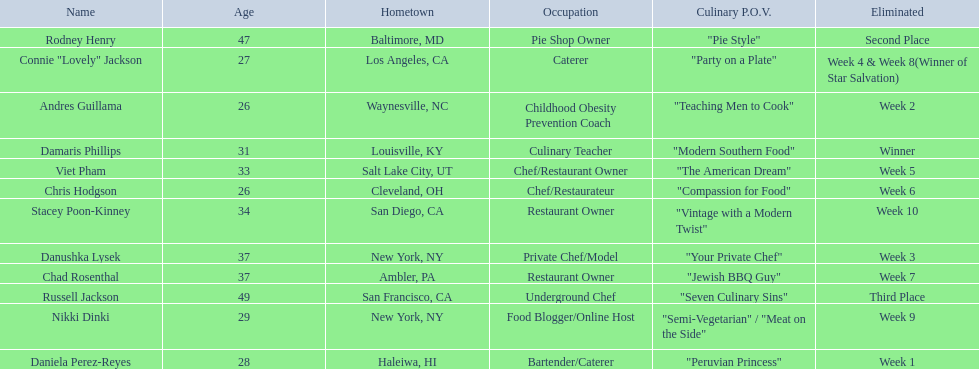Which food network star contestants are in their 20s? Nikki Dinki, Chris Hodgson, Connie "Lovely" Jackson, Andres Guillama, Daniela Perez-Reyes. Can you parse all the data within this table? {'header': ['Name', 'Age', 'Hometown', 'Occupation', 'Culinary P.O.V.', 'Eliminated'], 'rows': [['Rodney Henry', '47', 'Baltimore, MD', 'Pie Shop Owner', '"Pie Style"', 'Second Place'], ['Connie "Lovely" Jackson', '27', 'Los Angeles, CA', 'Caterer', '"Party on a Plate"', 'Week 4 & Week 8(Winner of Star Salvation)'], ['Andres Guillama', '26', 'Waynesville, NC', 'Childhood Obesity Prevention Coach', '"Teaching Men to Cook"', 'Week 2'], ['Damaris Phillips', '31', 'Louisville, KY', 'Culinary Teacher', '"Modern Southern Food"', 'Winner'], ['Viet Pham', '33', 'Salt Lake City, UT', 'Chef/Restaurant Owner', '"The American Dream"', 'Week 5'], ['Chris Hodgson', '26', 'Cleveland, OH', 'Chef/Restaurateur', '"Compassion for Food"', 'Week 6'], ['Stacey Poon-Kinney', '34', 'San Diego, CA', 'Restaurant Owner', '"Vintage with a Modern Twist"', 'Week 10'], ['Danushka Lysek', '37', 'New York, NY', 'Private Chef/Model', '"Your Private Chef"', 'Week 3'], ['Chad Rosenthal', '37', 'Ambler, PA', 'Restaurant Owner', '"Jewish BBQ Guy"', 'Week 7'], ['Russell Jackson', '49', 'San Francisco, CA', 'Underground Chef', '"Seven Culinary Sins"', 'Third Place'], ['Nikki Dinki', '29', 'New York, NY', 'Food Blogger/Online Host', '"Semi-Vegetarian" / "Meat on the Side"', 'Week 9'], ['Daniela Perez-Reyes', '28', 'Haleiwa, HI', 'Bartender/Caterer', '"Peruvian Princess"', 'Week 1']]} Of these contestants, which one is the same age as chris hodgson? Andres Guillama. 